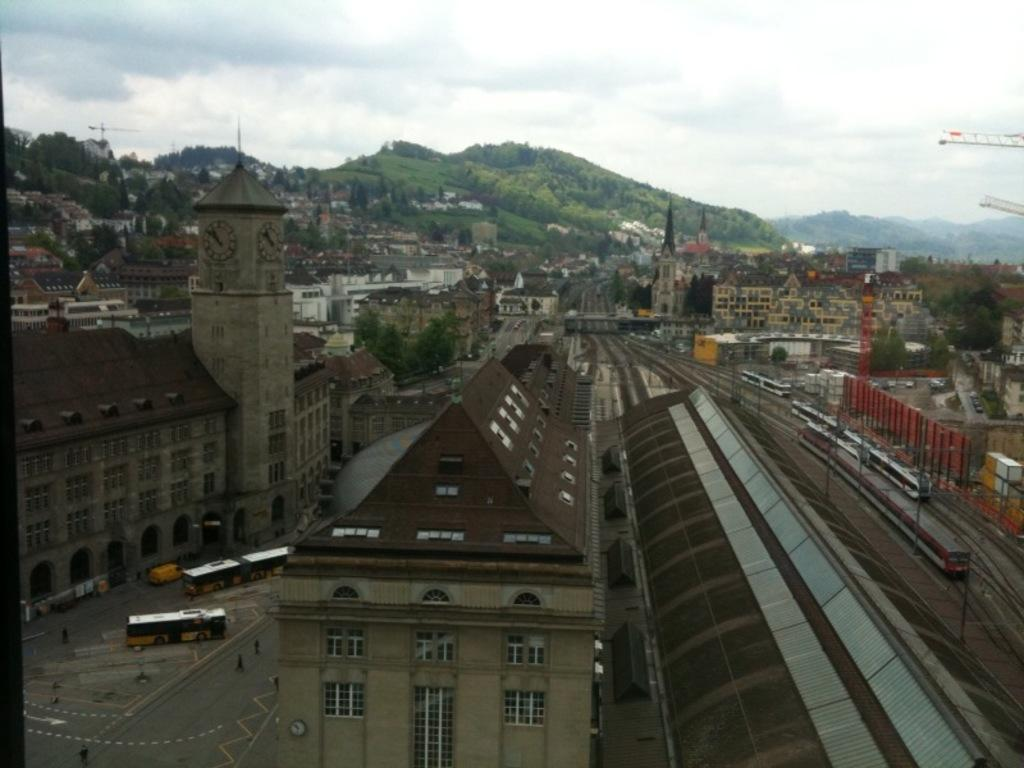What type of structures can be seen in the image? There are buildings in the image. What is happening on the road in the image? There are vehicles and people on the road in the image. What mode of transportation can be seen on the tracks in the image? There are trains on the tracks in the image. What type of landmark is present in the image? There is a clock tower in the image. What type of construction equipment can be seen in the image? There are cranes in the image. What natural feature is visible in the image? There are mountains covered with trees and plants in the image. Can you tell me how many grapes are hanging from the clock tower in the image? There are no grapes present in the image, and they are not hanging from the clock tower. What is the moon's position in the image? The moon is not visible in the image. 